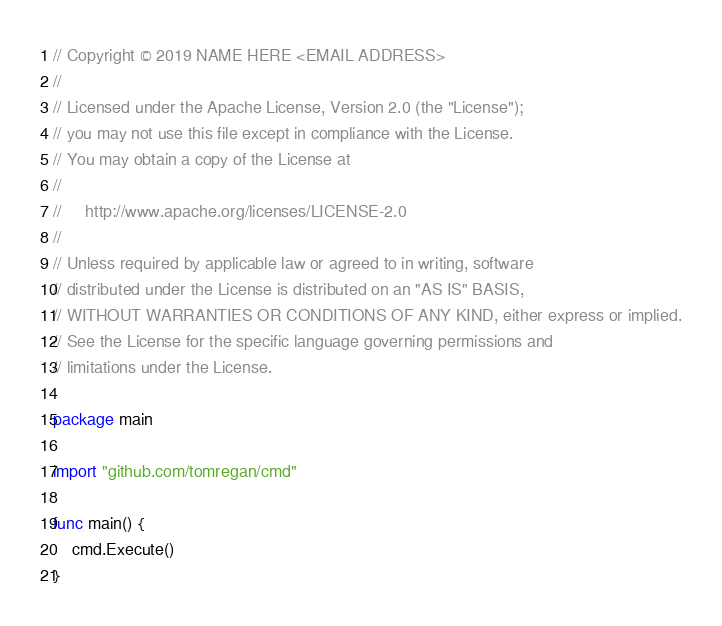Convert code to text. <code><loc_0><loc_0><loc_500><loc_500><_Go_>// Copyright © 2019 NAME HERE <EMAIL ADDRESS>
//
// Licensed under the Apache License, Version 2.0 (the "License");
// you may not use this file except in compliance with the License.
// You may obtain a copy of the License at
//
//     http://www.apache.org/licenses/LICENSE-2.0
//
// Unless required by applicable law or agreed to in writing, software
// distributed under the License is distributed on an "AS IS" BASIS,
// WITHOUT WARRANTIES OR CONDITIONS OF ANY KIND, either express or implied.
// See the License for the specific language governing permissions and
// limitations under the License.

package main

import "github.com/tomregan/cmd"

func main() {
	cmd.Execute()
}
</code> 